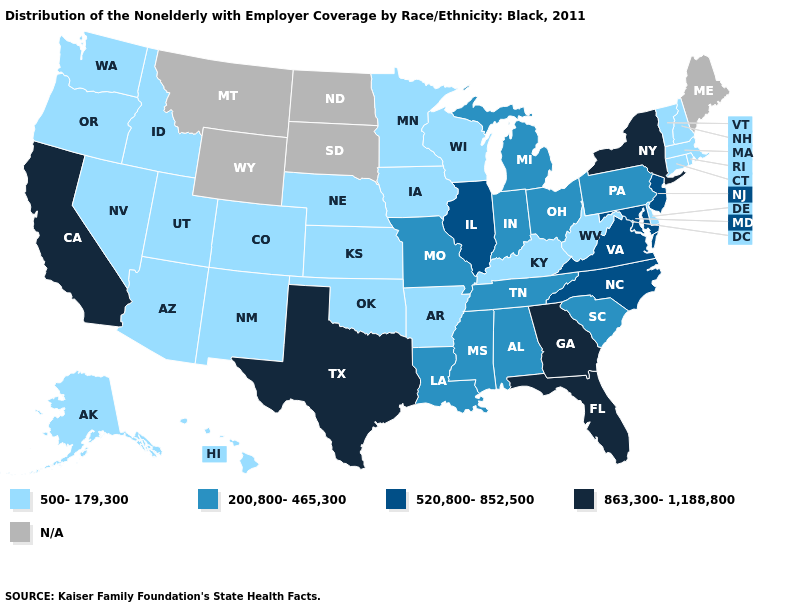Name the states that have a value in the range N/A?
Short answer required. Maine, Montana, North Dakota, South Dakota, Wyoming. What is the value of California?
Short answer required. 863,300-1,188,800. Among the states that border New Mexico , which have the lowest value?
Give a very brief answer. Arizona, Colorado, Oklahoma, Utah. What is the value of Nebraska?
Keep it brief. 500-179,300. What is the lowest value in the USA?
Give a very brief answer. 500-179,300. Does Georgia have the highest value in the South?
Short answer required. Yes. What is the lowest value in the USA?
Be succinct. 500-179,300. Does Michigan have the lowest value in the USA?
Give a very brief answer. No. Name the states that have a value in the range N/A?
Answer briefly. Maine, Montana, North Dakota, South Dakota, Wyoming. Does the map have missing data?
Keep it brief. Yes. What is the lowest value in states that border California?
Answer briefly. 500-179,300. Does the map have missing data?
Give a very brief answer. Yes. What is the value of Wisconsin?
Keep it brief. 500-179,300. What is the lowest value in the USA?
Give a very brief answer. 500-179,300. 